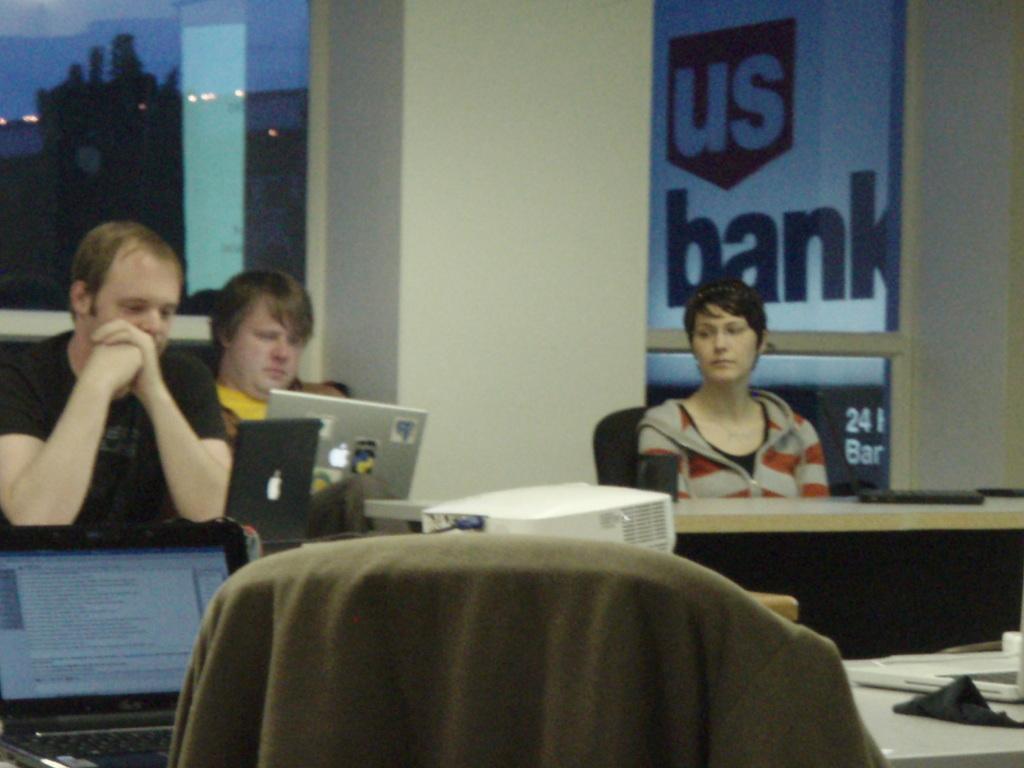Could you give a brief overview of what you see in this image? In this image there are three person. A woman is sitting on the chair. There is laptop projector on the table. In the background there is a board named as Us Bank,tree and a sky. 